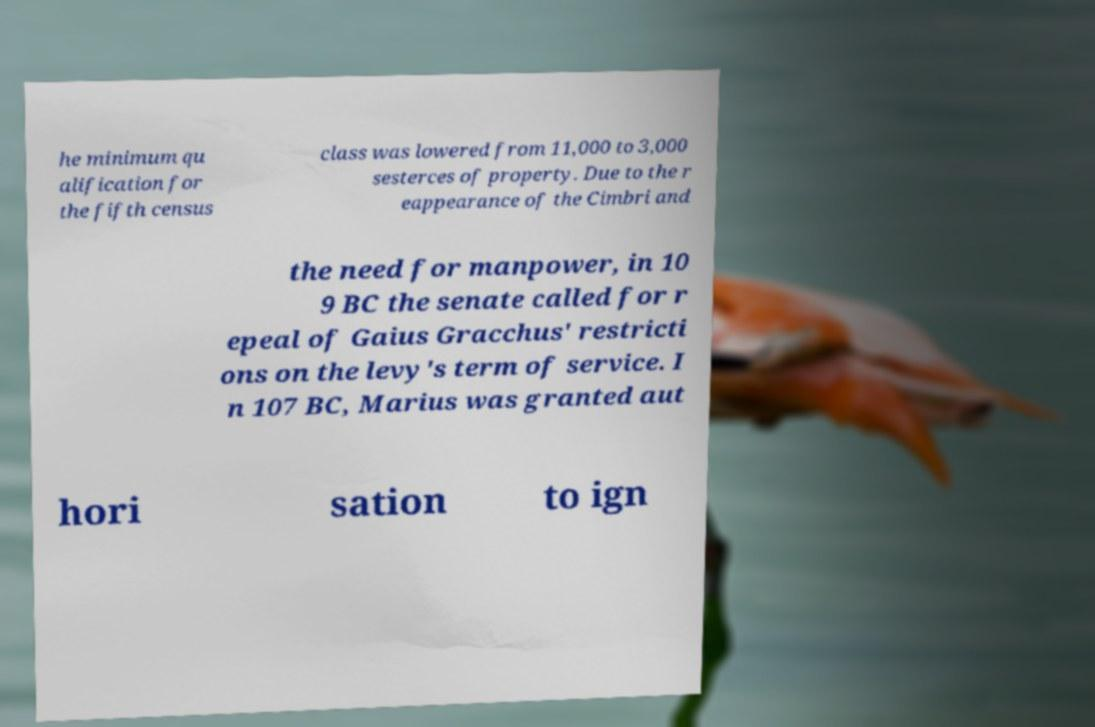Could you assist in decoding the text presented in this image and type it out clearly? he minimum qu alification for the fifth census class was lowered from 11,000 to 3,000 sesterces of property. Due to the r eappearance of the Cimbri and the need for manpower, in 10 9 BC the senate called for r epeal of Gaius Gracchus' restricti ons on the levy's term of service. I n 107 BC, Marius was granted aut hori sation to ign 